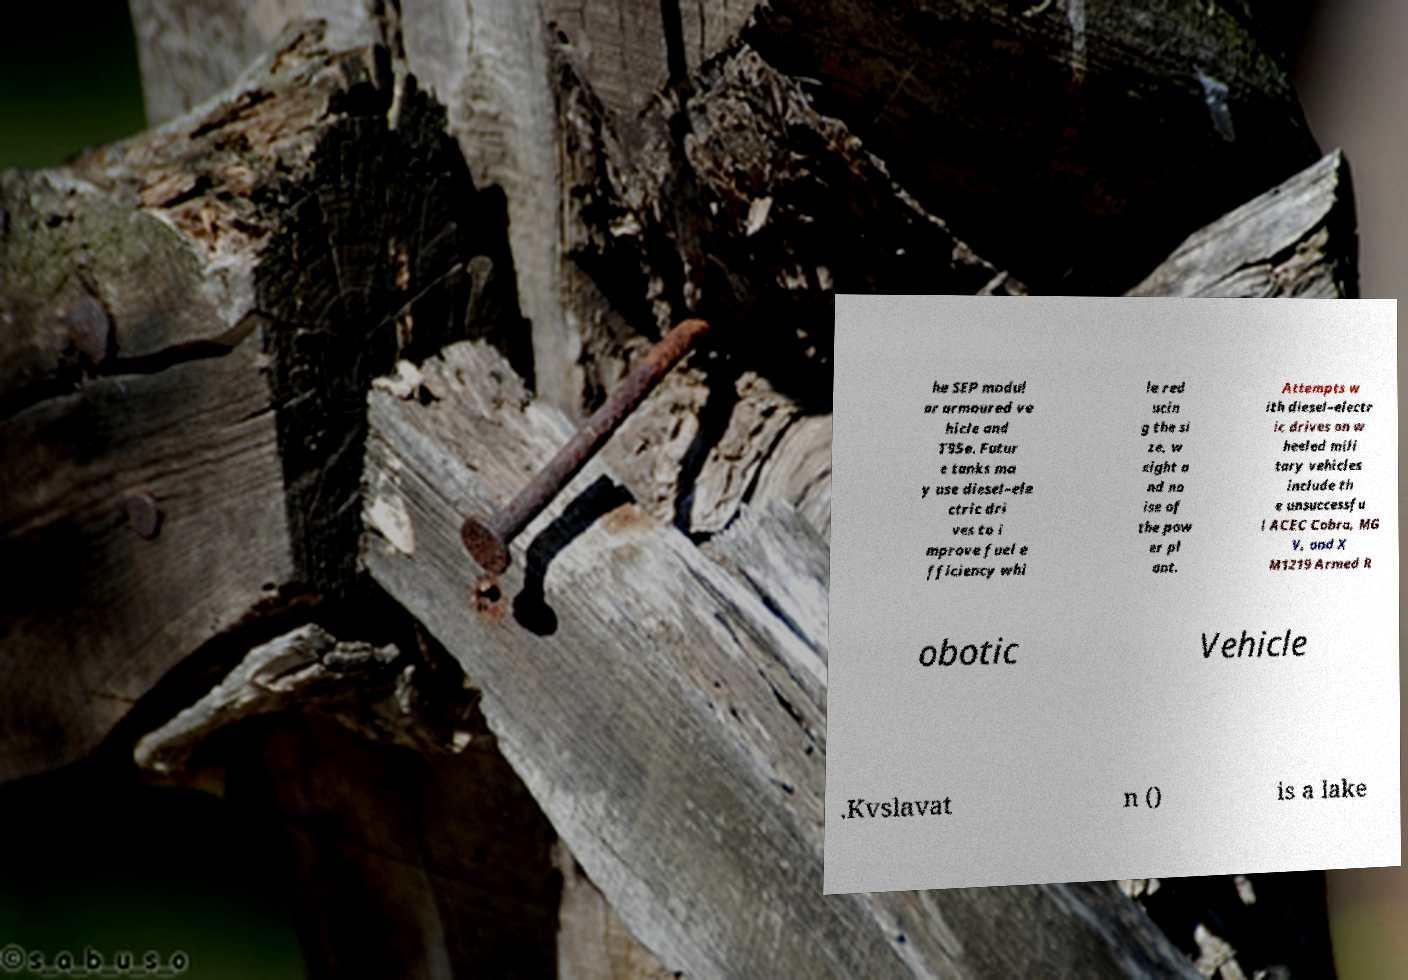Please read and relay the text visible in this image. What does it say? he SEP modul ar armoured ve hicle and T95e. Futur e tanks ma y use diesel–ele ctric dri ves to i mprove fuel e fficiency whi le red ucin g the si ze, w eight a nd no ise of the pow er pl ant. Attempts w ith diesel–electr ic drives on w heeled mili tary vehicles include th e unsuccessfu l ACEC Cobra, MG V, and X M1219 Armed R obotic Vehicle .Kvslavat n () is a lake 